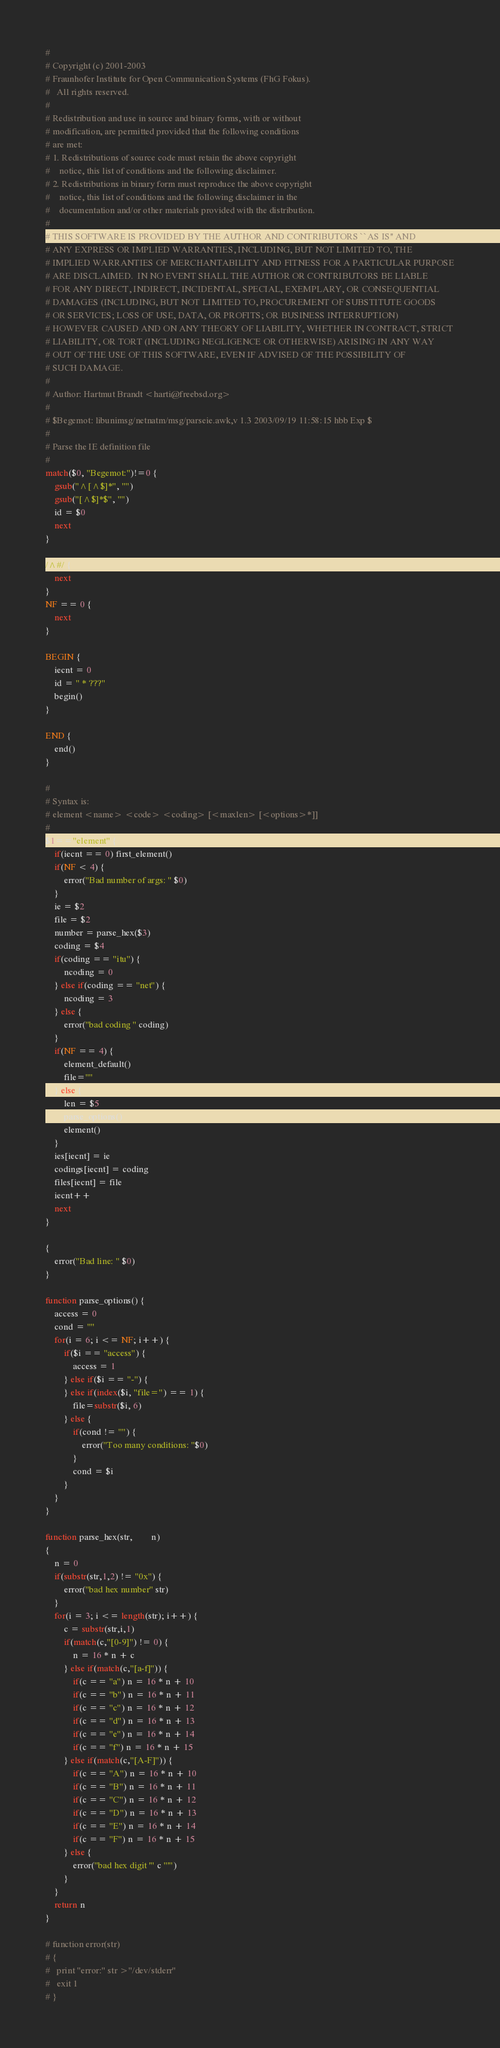Convert code to text. <code><loc_0><loc_0><loc_500><loc_500><_Awk_>#
# Copyright (c) 2001-2003
# Fraunhofer Institute for Open Communication Systems (FhG Fokus).
# 	All rights reserved.
#
# Redistribution and use in source and binary forms, with or without
# modification, are permitted provided that the following conditions
# are met:
# 1. Redistributions of source code must retain the above copyright
#    notice, this list of conditions and the following disclaimer.
# 2. Redistributions in binary form must reproduce the above copyright
#    notice, this list of conditions and the following disclaimer in the
#    documentation and/or other materials provided with the distribution.
#
# THIS SOFTWARE IS PROVIDED BY THE AUTHOR AND CONTRIBUTORS ``AS IS'' AND
# ANY EXPRESS OR IMPLIED WARRANTIES, INCLUDING, BUT NOT LIMITED TO, THE
# IMPLIED WARRANTIES OF MERCHANTABILITY AND FITNESS FOR A PARTICULAR PURPOSE
# ARE DISCLAIMED.  IN NO EVENT SHALL THE AUTHOR OR CONTRIBUTORS BE LIABLE
# FOR ANY DIRECT, INDIRECT, INCIDENTAL, SPECIAL, EXEMPLARY, OR CONSEQUENTIAL
# DAMAGES (INCLUDING, BUT NOT LIMITED TO, PROCUREMENT OF SUBSTITUTE GOODS
# OR SERVICES; LOSS OF USE, DATA, OR PROFITS; OR BUSINESS INTERRUPTION)
# HOWEVER CAUSED AND ON ANY THEORY OF LIABILITY, WHETHER IN CONTRACT, STRICT
# LIABILITY, OR TORT (INCLUDING NEGLIGENCE OR OTHERWISE) ARISING IN ANY WAY
# OUT OF THE USE OF THIS SOFTWARE, EVEN IF ADVISED OF THE POSSIBILITY OF
# SUCH DAMAGE.
#
# Author: Hartmut Brandt <harti@freebsd.org>
#
# $Begemot: libunimsg/netnatm/msg/parseie.awk,v 1.3 2003/09/19 11:58:15 hbb Exp $
#
# Parse the IE definition file
#
match($0, "Begemot:")!=0 {
	gsub("^[^$]*", "")
	gsub("[^$]*$", "")
	id = $0
	next
}

/^#/ {
	next
}
NF == 0 {
	next
}

BEGIN {
	iecnt = 0
	id = " * ???"
	begin()
}

END {
	end()
}

#
# Syntax is:
# element <name> <code> <coding> [<maxlen> [<options>*]]
#
$1=="element" {
	if(iecnt == 0) first_element()
	if(NF < 4) {
		error("Bad number of args: " $0)
	}
	ie = $2
	file = $2
	number = parse_hex($3)
	coding = $4
	if(coding == "itu") {
		ncoding = 0
	} else if(coding == "net") {
		ncoding = 3
	} else {
		error("bad coding " coding)
	}
	if(NF == 4) {
		element_default()
		file=""
	} else {
		len = $5
		parse_options()
		element()
	}
	ies[iecnt] = ie
	codings[iecnt] = coding
	files[iecnt] = file
	iecnt++
	next
}

{
	error("Bad line: " $0)
}

function parse_options() {
	access = 0
	cond = ""
	for(i = 6; i <= NF; i++) {
		if($i == "access") {
			access = 1
		} else if($i == "-") {
		} else if(index($i, "file=") == 1) {
			file=substr($i, 6)
		} else {
			if(cond != "") {
				error("Too many conditions: "$0)
			}
			cond = $i
		}
	}
}

function parse_hex(str,		n)
{
	n = 0
	if(substr(str,1,2) != "0x") {
		error("bad hex number" str)
	}
	for(i = 3; i <= length(str); i++) {
		c = substr(str,i,1)
		if(match(c,"[0-9]") != 0) {
			n = 16 * n + c
		} else if(match(c,"[a-f]")) {
			if(c == "a") n = 16 * n + 10
			if(c == "b") n = 16 * n + 11
			if(c == "c") n = 16 * n + 12
			if(c == "d") n = 16 * n + 13
			if(c == "e") n = 16 * n + 14
			if(c == "f") n = 16 * n + 15
		} else if(match(c,"[A-F]")) {
			if(c == "A") n = 16 * n + 10
			if(c == "B") n = 16 * n + 11
			if(c == "C") n = 16 * n + 12
			if(c == "D") n = 16 * n + 13
			if(c == "E") n = 16 * n + 14
			if(c == "F") n = 16 * n + 15
		} else {
			error("bad hex digit '" c "'")
		}
	}
	return n
}

# function error(str)
# {
# 	print "error:" str >"/dev/stderr"
# 	exit 1
# }

</code> 